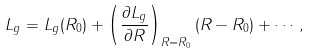Convert formula to latex. <formula><loc_0><loc_0><loc_500><loc_500>L _ { g } = L _ { g } ( R _ { 0 } ) + \left ( \frac { \partial L _ { g } } { \partial R } \right ) _ { R = R _ { 0 } } ( R - R _ { 0 } ) + \cdots \, ,</formula> 